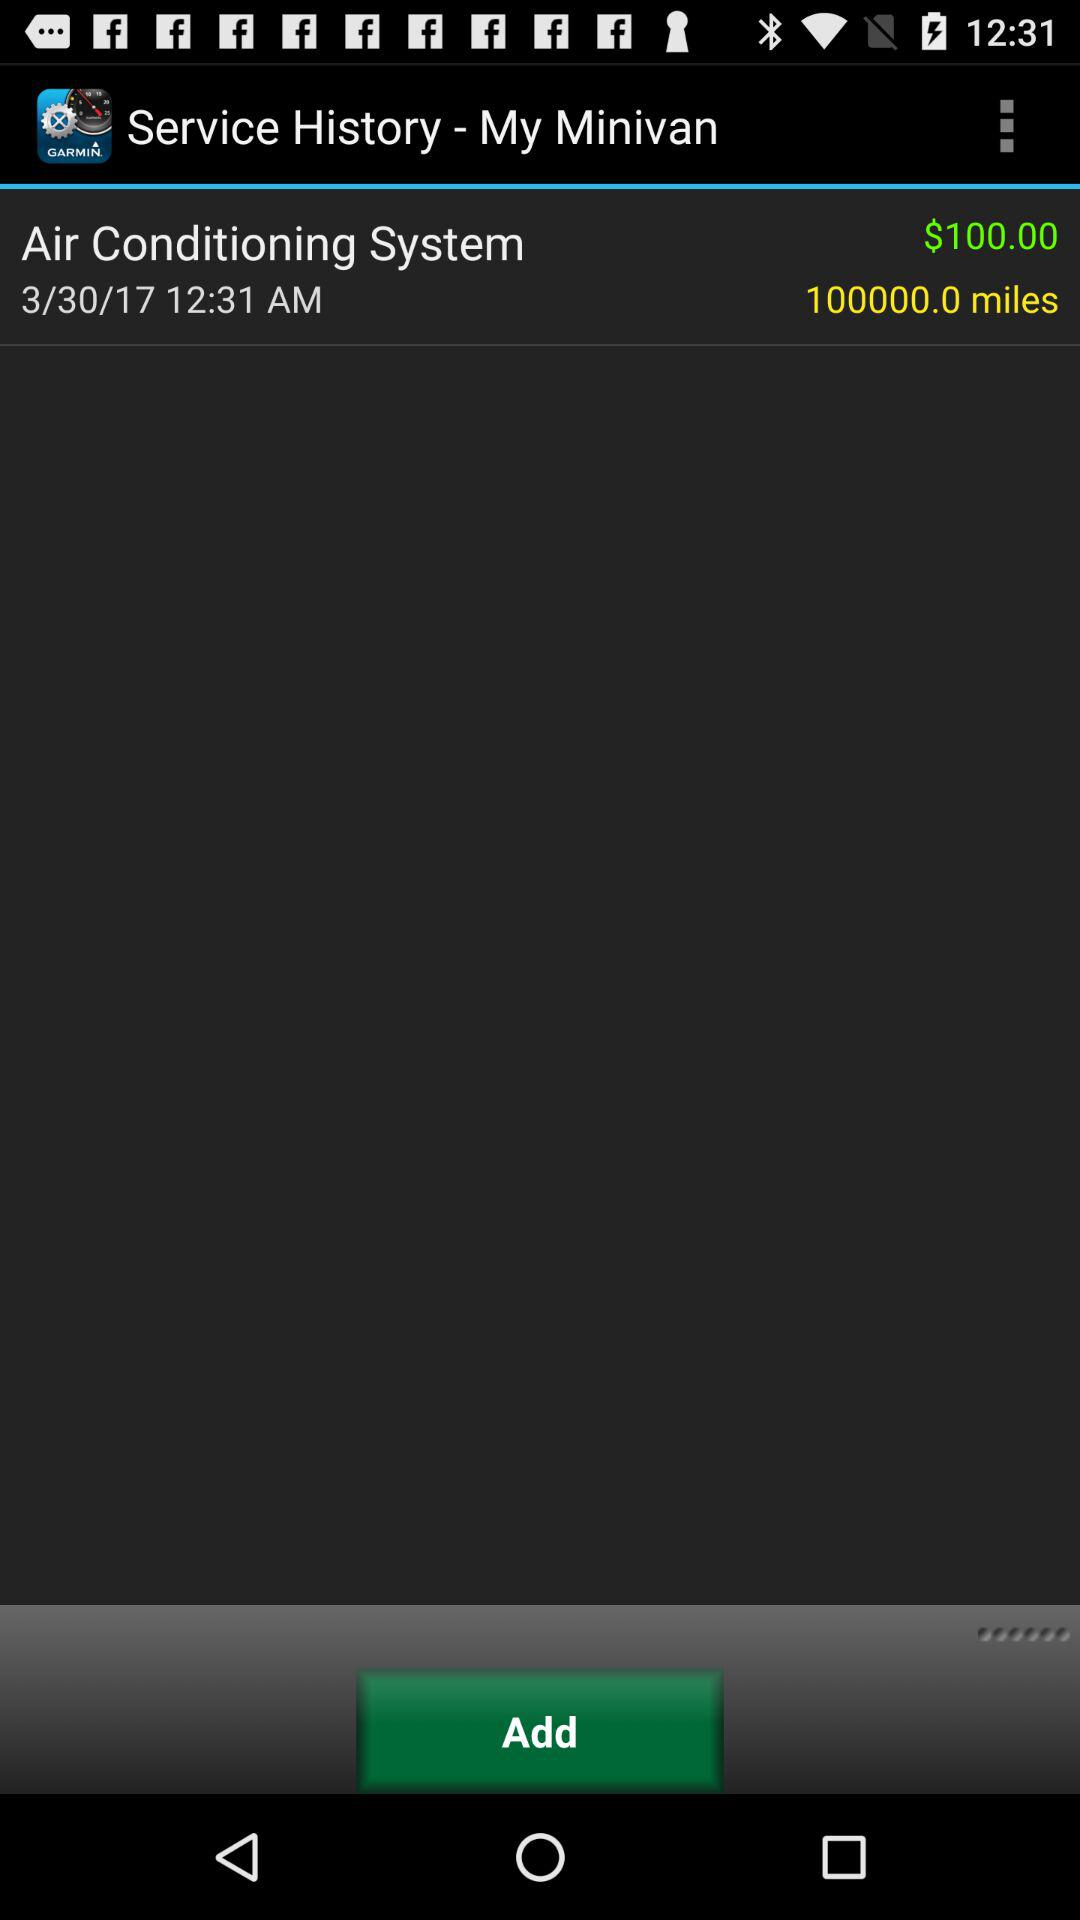What is the make and model of the mini van?
When the provided information is insufficient, respond with <no answer>. <no answer> 